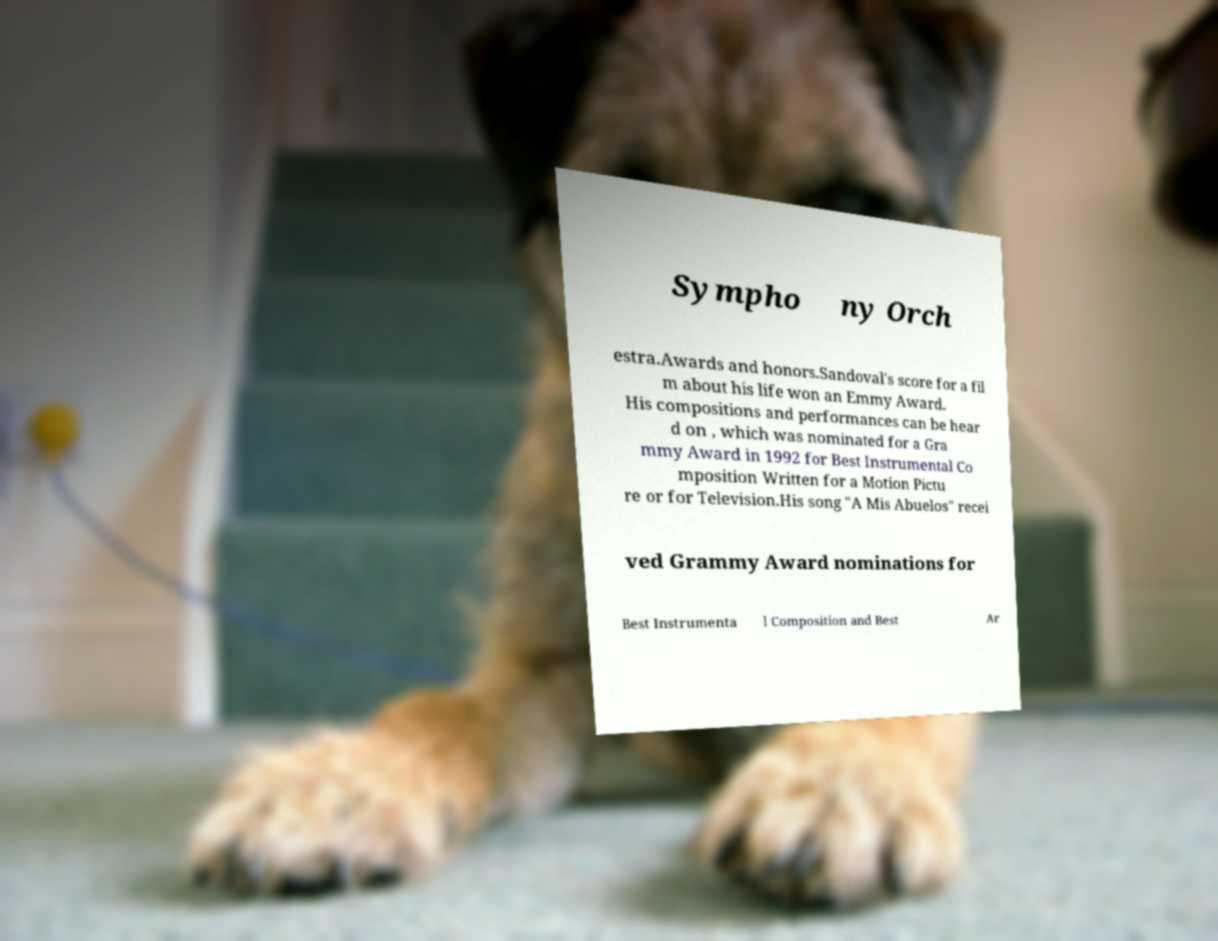I need the written content from this picture converted into text. Can you do that? Sympho ny Orch estra.Awards and honors.Sandoval's score for a fil m about his life won an Emmy Award. His compositions and performances can be hear d on , which was nominated for a Gra mmy Award in 1992 for Best Instrumental Co mposition Written for a Motion Pictu re or for Television.His song "A Mis Abuelos" recei ved Grammy Award nominations for Best Instrumenta l Composition and Best Ar 